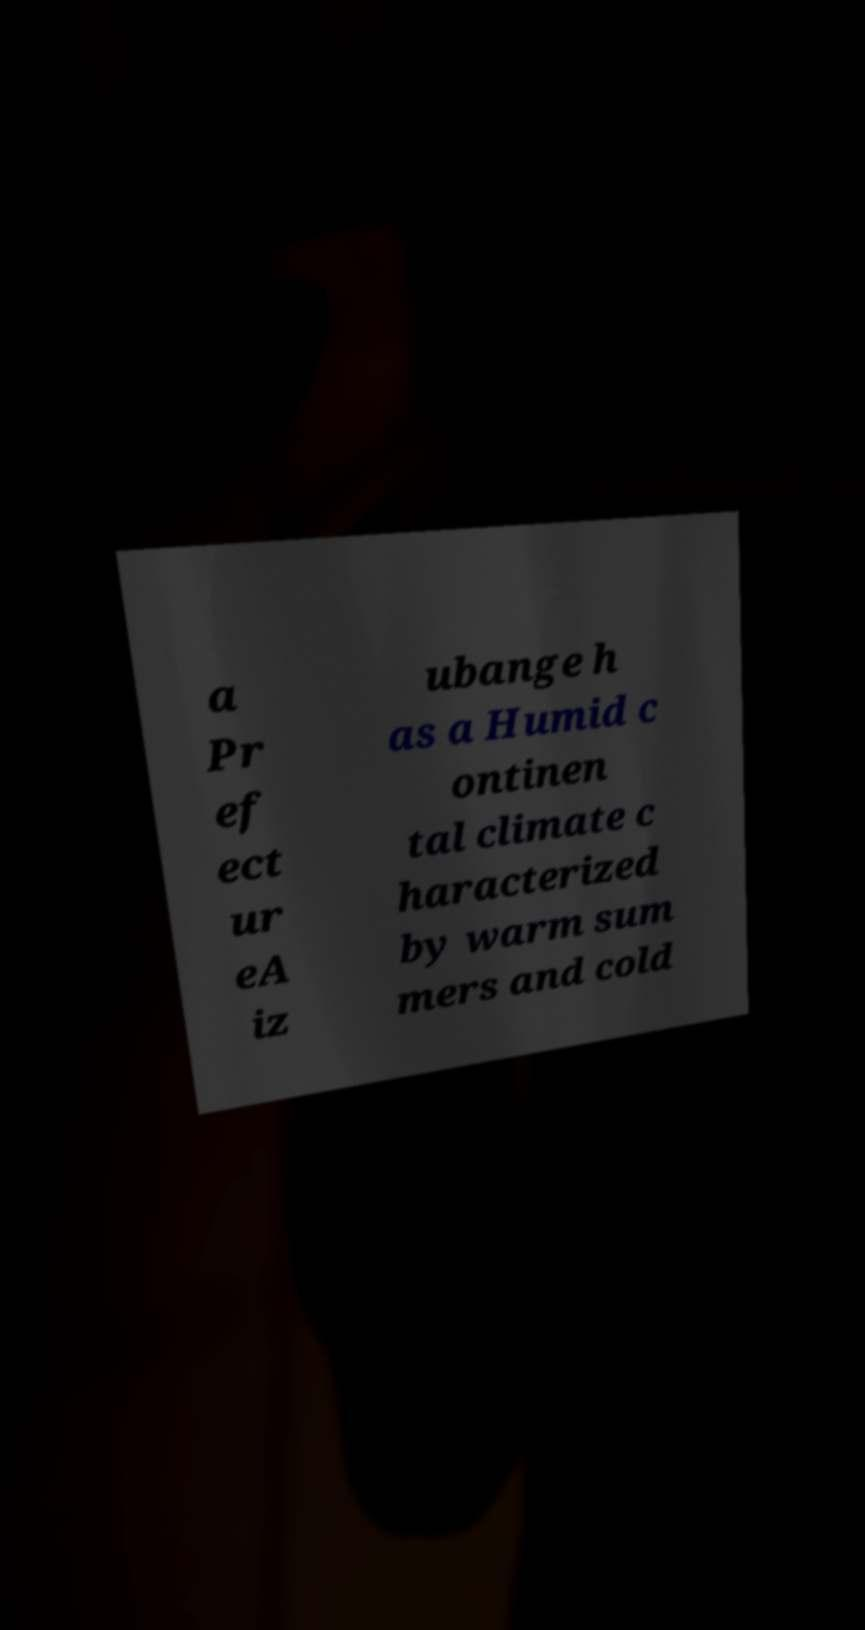Can you read and provide the text displayed in the image?This photo seems to have some interesting text. Can you extract and type it out for me? a Pr ef ect ur eA iz ubange h as a Humid c ontinen tal climate c haracterized by warm sum mers and cold 